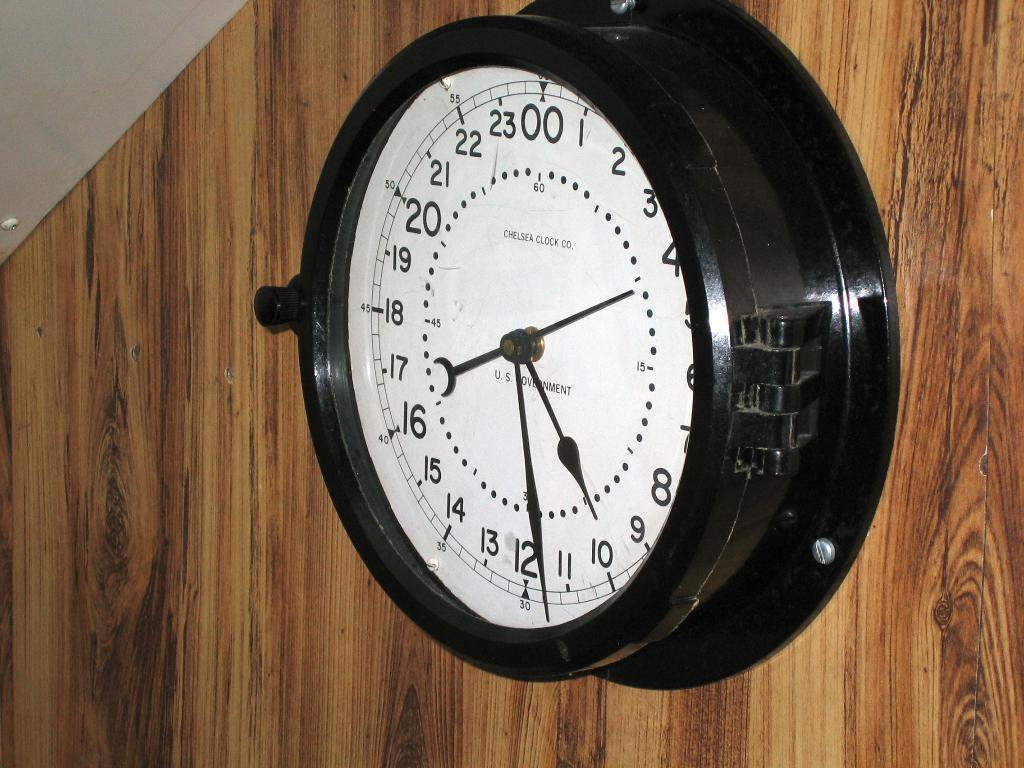Provide a one-sentence caption for the provided image. The clock shows one hand at around 10 and another at around 12. 